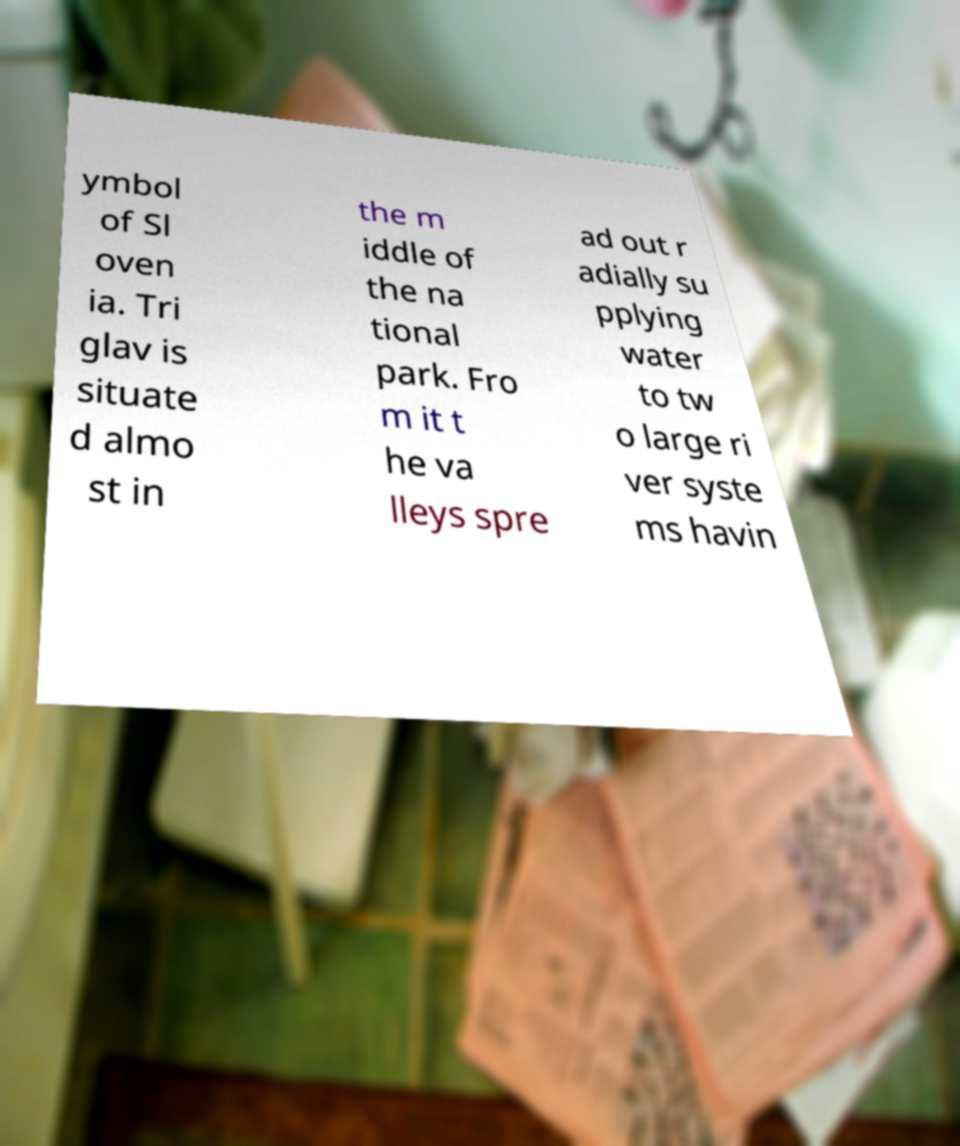There's text embedded in this image that I need extracted. Can you transcribe it verbatim? ymbol of Sl oven ia. Tri glav is situate d almo st in the m iddle of the na tional park. Fro m it t he va lleys spre ad out r adially su pplying water to tw o large ri ver syste ms havin 